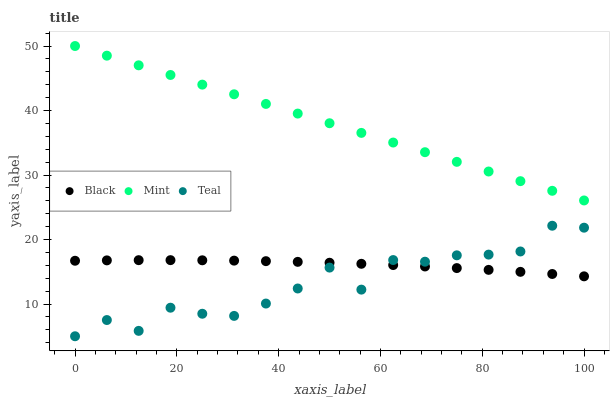Does Teal have the minimum area under the curve?
Answer yes or no. Yes. Does Mint have the maximum area under the curve?
Answer yes or no. Yes. Does Black have the minimum area under the curve?
Answer yes or no. No. Does Black have the maximum area under the curve?
Answer yes or no. No. Is Mint the smoothest?
Answer yes or no. Yes. Is Teal the roughest?
Answer yes or no. Yes. Is Black the smoothest?
Answer yes or no. No. Is Black the roughest?
Answer yes or no. No. Does Teal have the lowest value?
Answer yes or no. Yes. Does Black have the lowest value?
Answer yes or no. No. Does Mint have the highest value?
Answer yes or no. Yes. Does Teal have the highest value?
Answer yes or no. No. Is Black less than Mint?
Answer yes or no. Yes. Is Mint greater than Teal?
Answer yes or no. Yes. Does Black intersect Teal?
Answer yes or no. Yes. Is Black less than Teal?
Answer yes or no. No. Is Black greater than Teal?
Answer yes or no. No. Does Black intersect Mint?
Answer yes or no. No. 